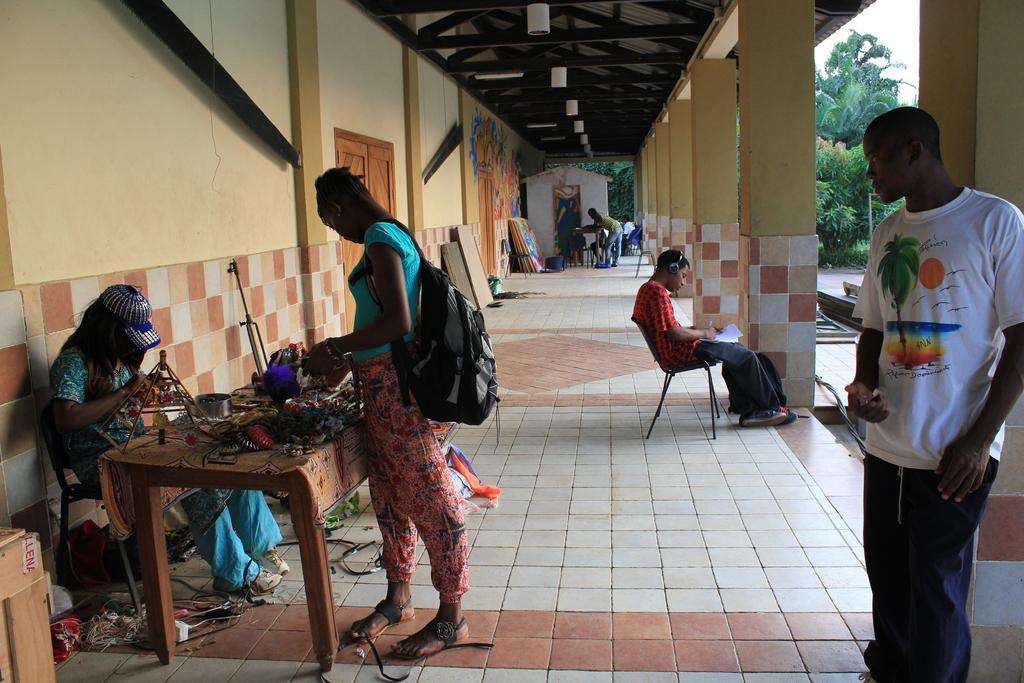In one or two sentences, can you explain what this image depicts? In the image we can see there are many people wearing clothes, some are standing and some of them are sitting. There is a chair, table, on the table there are many things, this is a bag, light, pillar, floor, trees and a sky. This person is wearing a cap and shoes. 